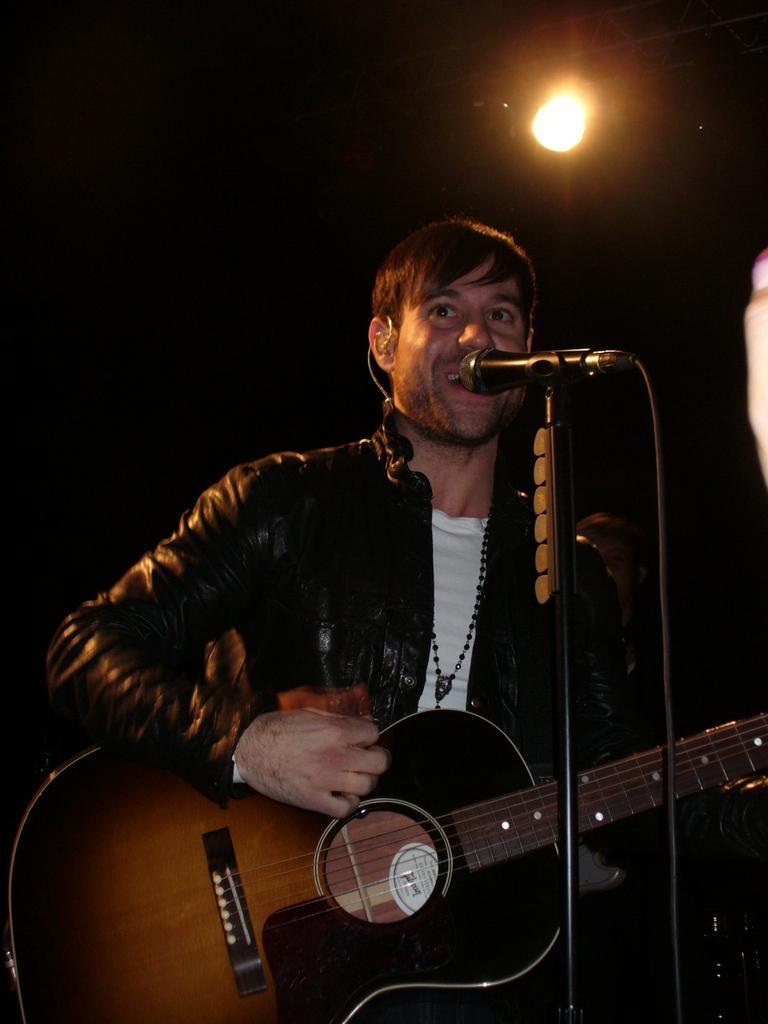Could you give a brief overview of what you see in this image? Here a person is playing guitar in front of a mic. In the background there is a light. 